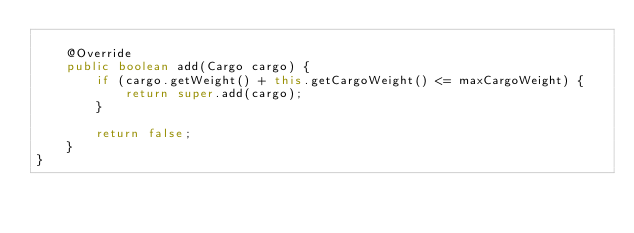<code> <loc_0><loc_0><loc_500><loc_500><_Java_>    
    @Override
    public boolean add(Cargo cargo) {
        if (cargo.getWeight() + this.getCargoWeight() <= maxCargoWeight) {
            return super.add(cargo);
        }

        return false;
    }
}
</code> 